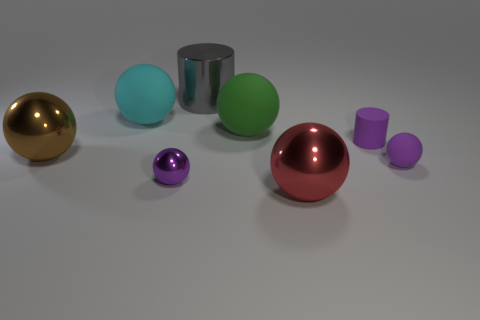How many other things are the same color as the small rubber cylinder?
Provide a short and direct response. 2. What is the color of the small object that is to the right of the tiny cylinder?
Give a very brief answer. Purple. Is there a blue metallic cylinder of the same size as the brown metallic ball?
Offer a very short reply. No. What material is the green object that is the same size as the cyan thing?
Keep it short and to the point. Rubber. How many objects are balls that are right of the big brown shiny ball or balls behind the purple cylinder?
Ensure brevity in your answer.  5. Are there any other large matte objects that have the same shape as the big cyan rubber object?
Ensure brevity in your answer.  Yes. What material is the other tiny ball that is the same color as the small matte ball?
Your response must be concise. Metal. What number of matte objects are either small purple spheres or small purple things?
Give a very brief answer. 2. The large brown thing is what shape?
Ensure brevity in your answer.  Sphere. How many purple things have the same material as the cyan object?
Make the answer very short. 2. 